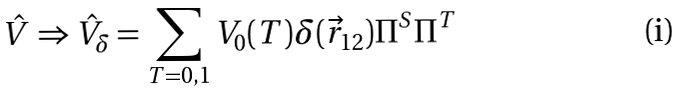<formula> <loc_0><loc_0><loc_500><loc_500>\hat { V } \Rightarrow \hat { V } _ { \delta } = \sum _ { T = 0 , 1 } V _ { 0 } ( T ) \delta ( \vec { r } _ { 1 2 } ) \Pi ^ { S } \Pi ^ { T } \,</formula> 